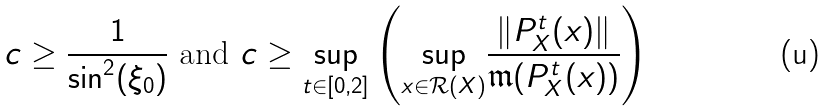Convert formula to latex. <formula><loc_0><loc_0><loc_500><loc_500>c \geq \frac { 1 } { \sin ^ { 2 } ( \xi _ { 0 } ) } \text {    and    } c \geq \sup _ { t \in [ 0 , 2 ] } \left ( \underset { x \in { \mathcal { R } ( X ) } } { \sup } { \frac { \| P _ { X } ^ { t } ( x ) \| } { \mathfrak { m } ( P _ { X } ^ { t } ( x ) ) } } \right )</formula> 